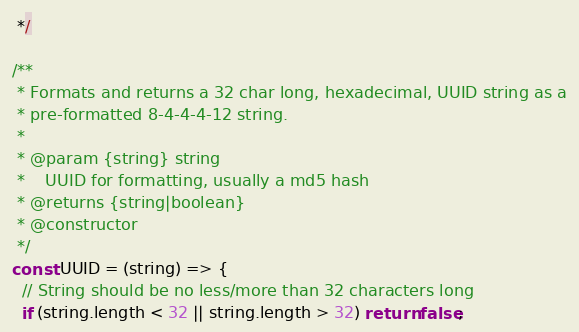Convert code to text. <code><loc_0><loc_0><loc_500><loc_500><_JavaScript_> */

/**
 * Formats and returns a 32 char long, hexadecimal, UUID string as a
 * pre-formatted 8-4-4-4-12 string.
 *
 * @param {string} string
 *    UUID for formatting, usually a md5 hash
 * @returns {string|boolean}
 * @constructor
 */
const UUID = (string) => {
  // String should be no less/more than 32 characters long
  if (string.length < 32 || string.length > 32) return false;</code> 